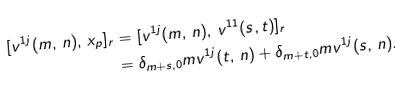Convert formula to latex. <formula><loc_0><loc_0><loc_500><loc_500>[ v ^ { 1 j } ( m , \, n ) , \, x _ { p } ] _ { r } & = [ v ^ { 1 j } ( m , \, n ) , \, v ^ { 1 1 } ( s , t ) ] _ { r } \\ & = \delta _ { m + s , 0 } m v ^ { 1 j } ( t , \, n ) + \delta _ { m + t , 0 } m v ^ { 1 j } ( s , \, n ) .</formula> 